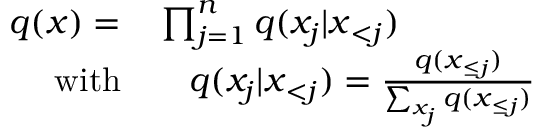Convert formula to latex. <formula><loc_0><loc_0><loc_500><loc_500>\begin{array} { r l } { q ( x ) = } & \prod _ { j = 1 } ^ { n } q ( x _ { j } | x _ { < j } ) } \\ { w i t h } & \quad q ( x _ { j } | x _ { < j } ) = \frac { q ( x _ { \leq j } ) } { \sum _ { x _ { j } } q ( x _ { \leq j } ) } } \end{array}</formula> 